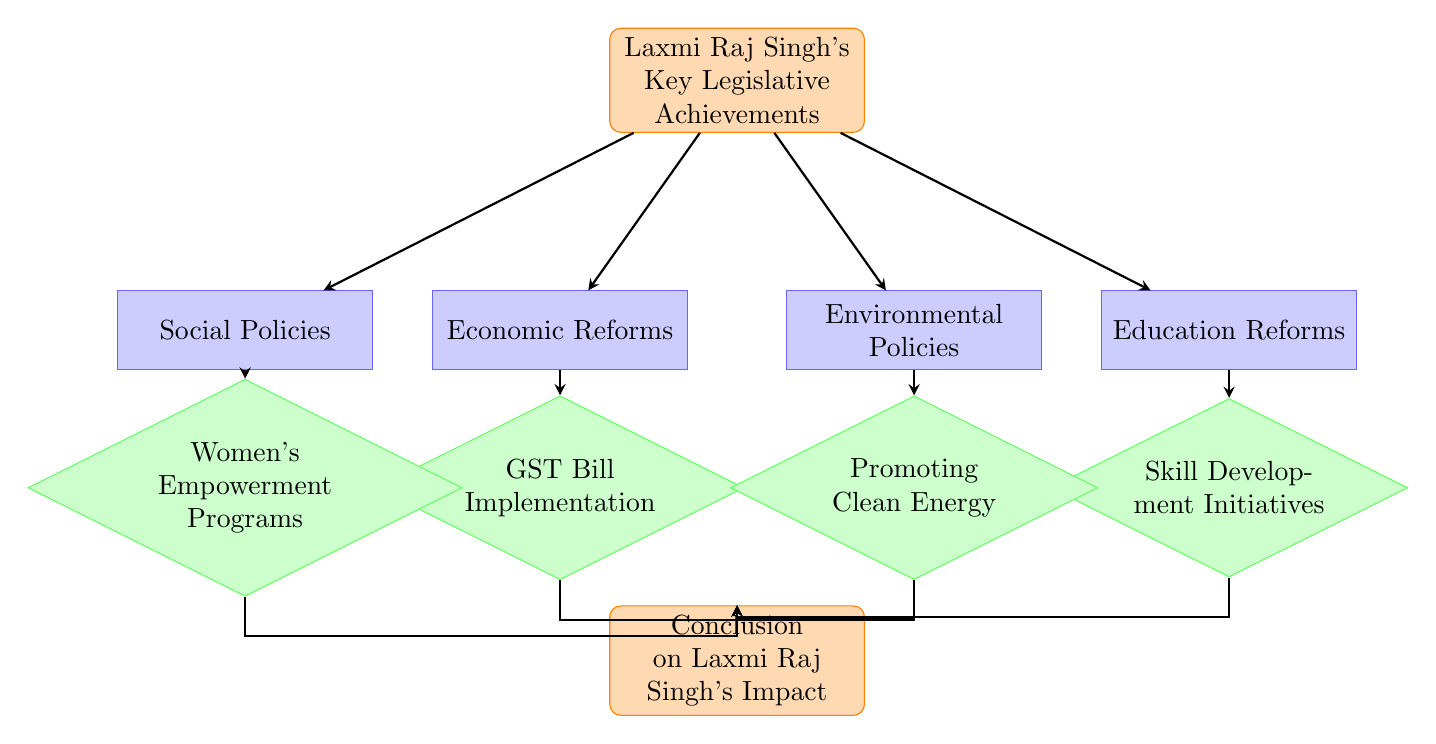What is the first step in Laxmi Raj Singh's key legislative achievements? The first step, represented as the starting point in the diagram, is "Laxmi Raj Singh's Key Legislative Achievements." This is the entry node from where all other nodes or processes branch out.
Answer: Laxmi Raj Singh's Key Legislative Achievements How many main categories of achievements are represented in the diagram? There are four main categories branching out from the starting node: Economic Reforms, Social Policies, Education Reforms, and Environmental Policies. Each of these categories further leads to specific legislative actions or decisions.
Answer: Four Which node leads to the conclusion if the GST Bill is implemented? If the GST Bill is implemented, it leads directly to the "Conclusion on Laxmi Raj Singh's Impact" node. The flow from the "GST Bill Implementation" decision leads to this conclusion.
Answer: Conclusion on Laxmi Raj Singh's Impact What legislative action falls under Social Policies? The legislative action that falls under Social Policies is "Women's Empowerment Programs." This is the subsequent decision node that is directly linked to Social Policies.
Answer: Women's Empowerment Programs Which two nodes are directly linked under Education Reforms? The two nodes that are directly linked under Education Reforms are "Education Reforms" and "Skill Development Initiatives." The flow goes from Education Reforms as a process to Skill Development Initiatives as a decision.
Answer: Skill Development Initiatives Which node represents promoting environmental sustainability? The node that represents promoting environmental sustainability is "Promoting Clean Energy." This is a decision node that follows the broader category of Environmental Policies.
Answer: Promoting Clean Energy What is the last node in the flow chart? The last node in the flow chart is "Conclusion on Laxmi Raj Singh's Impact." This node summarizes the impact of all preceding legislative achievements and decisions.
Answer: Conclusion on Laxmi Raj Singh's Impact What type of node is "GST Bill Implementation"? "GST Bill Implementation" is classified as a decision node in the flow chart. This indicates that it represents a critical decision to either proceed or not with the implementation.
Answer: Decision 